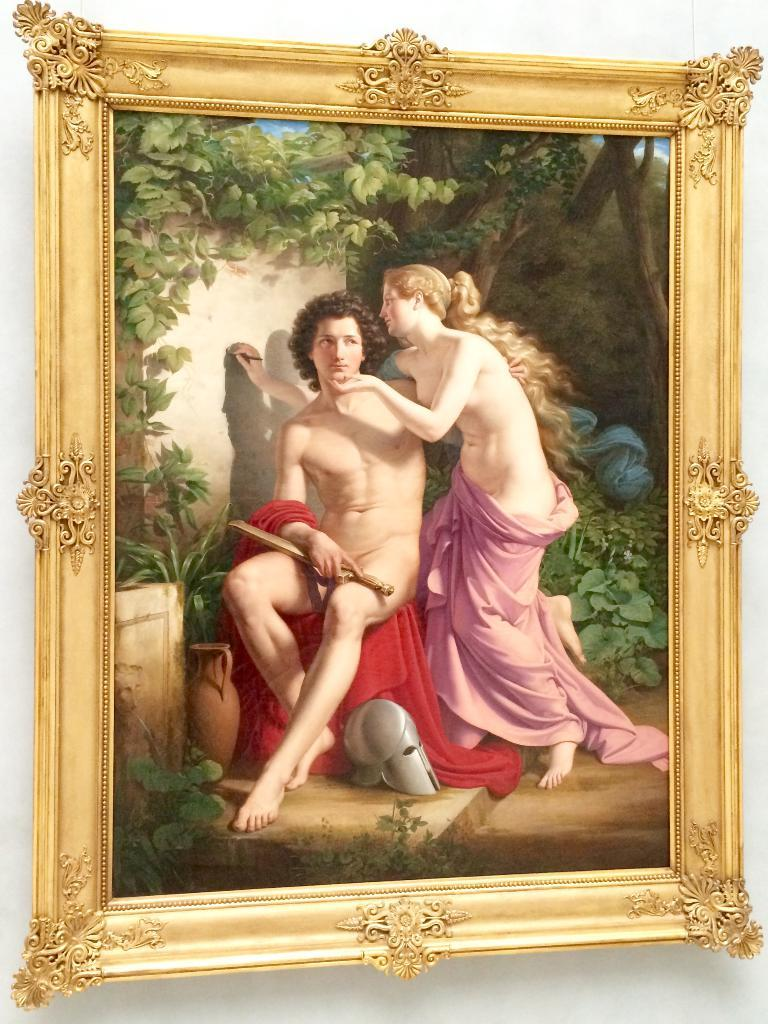What object is present in the image that typically holds a picture or artwork? There is a photo frame in the image. What is depicted within the photo frame? The photo frame contains a painting of two persons. Are there any additional elements in the painting besides the two persons? Yes, the painting includes plants. What can be seen behind the photo frame in the image? There is a wall in the background of the image. How many cactus legs are visible in the image? There are no cactus legs present in the image, as the image features a photo frame with a painting of two persons and plants, but no cactus. 